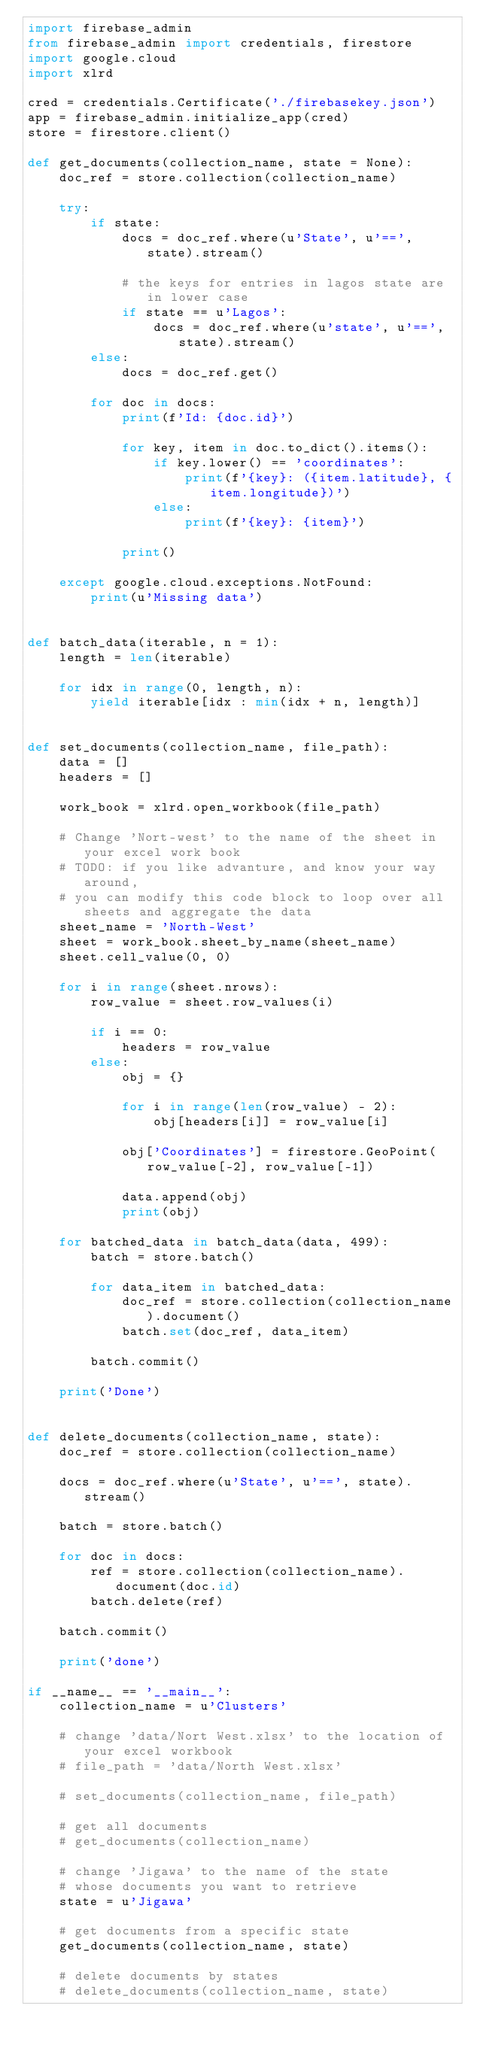<code> <loc_0><loc_0><loc_500><loc_500><_Python_>import firebase_admin
from firebase_admin import credentials, firestore
import google.cloud
import xlrd

cred = credentials.Certificate('./firebasekey.json')
app = firebase_admin.initialize_app(cred)
store = firestore.client()

def get_documents(collection_name, state = None):
    doc_ref = store.collection(collection_name)

    try:
        if state:
            docs = doc_ref.where(u'State', u'==', state).stream()

            # the keys for entries in lagos state are in lower case
            if state == u'Lagos':
                docs = doc_ref.where(u'state', u'==', state).stream()
        else:
            docs = doc_ref.get()

        for doc in docs:
            print(f'Id: {doc.id}')

            for key, item in doc.to_dict().items():
                if key.lower() == 'coordinates':
                    print(f'{key}: ({item.latitude}, {item.longitude})')
                else:
                    print(f'{key}: {item}')

            print()

    except google.cloud.exceptions.NotFound:
        print(u'Missing data')


def batch_data(iterable, n = 1):
    length = len(iterable)

    for idx in range(0, length, n):
        yield iterable[idx : min(idx + n, length)]


def set_documents(collection_name, file_path):
    data = []
    headers = []

    work_book = xlrd.open_workbook(file_path)

    # Change 'Nort-west' to the name of the sheet in your excel work book
    # TODO: if you like advanture, and know your way around, 
    # you can modify this code block to loop over all sheets and aggregate the data
    sheet_name = 'North-West'
    sheet = work_book.sheet_by_name(sheet_name)
    sheet.cell_value(0, 0)

    for i in range(sheet.nrows):
        row_value = sheet.row_values(i)

        if i == 0:
            headers = row_value
        else:
            obj = {}

            for i in range(len(row_value) - 2):
                obj[headers[i]] = row_value[i]

            obj['Coordinates'] = firestore.GeoPoint(row_value[-2], row_value[-1])

            data.append(obj)
            print(obj)

    for batched_data in batch_data(data, 499):
        batch = store.batch()

        for data_item in batched_data:
            doc_ref = store.collection(collection_name).document()
            batch.set(doc_ref, data_item)

        batch.commit()

    print('Done')


def delete_documents(collection_name, state):
    doc_ref = store.collection(collection_name)

    docs = doc_ref.where(u'State', u'==', state).stream()

    batch = store.batch()

    for doc in docs:
        ref = store.collection(collection_name).document(doc.id)
        batch.delete(ref)

    batch.commit()

    print('done')

if __name__ == '__main__':
    collection_name = u'Clusters'

    # change 'data/Nort West.xlsx' to the location of your excel workbook
    # file_path = 'data/North West.xlsx'

    # set_documents(collection_name, file_path)

    # get all documents
    # get_documents(collection_name)

    # change 'Jigawa' to the name of the state 
    # whose documents you want to retrieve
    state = u'Jigawa'

    # get documents from a specific state
    get_documents(collection_name, state)

    # delete documents by states
    # delete_documents(collection_name, state)</code> 